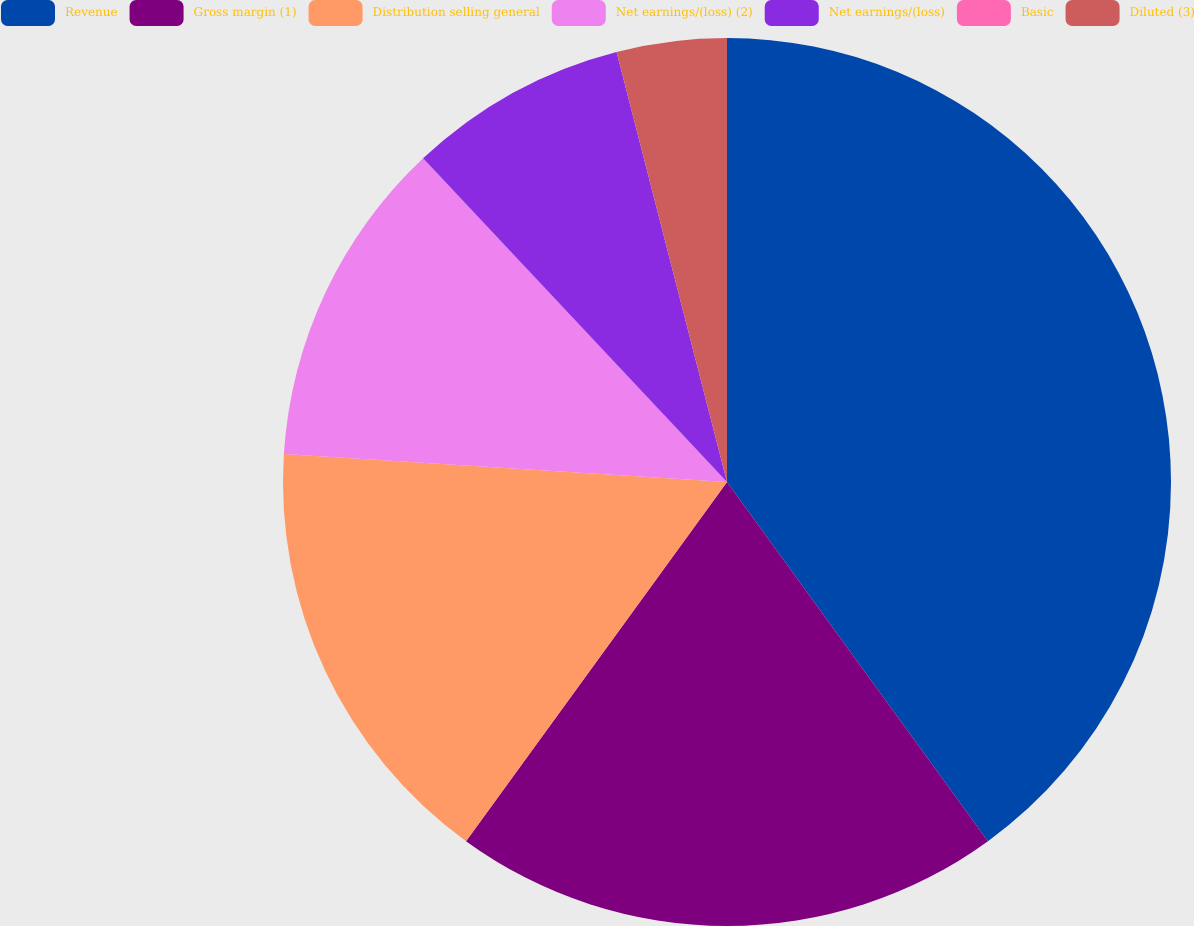Convert chart. <chart><loc_0><loc_0><loc_500><loc_500><pie_chart><fcel>Revenue<fcel>Gross margin (1)<fcel>Distribution selling general<fcel>Net earnings/(loss) (2)<fcel>Net earnings/(loss)<fcel>Basic<fcel>Diluted (3)<nl><fcel>40.0%<fcel>20.0%<fcel>16.0%<fcel>12.0%<fcel>8.0%<fcel>0.0%<fcel>4.0%<nl></chart> 